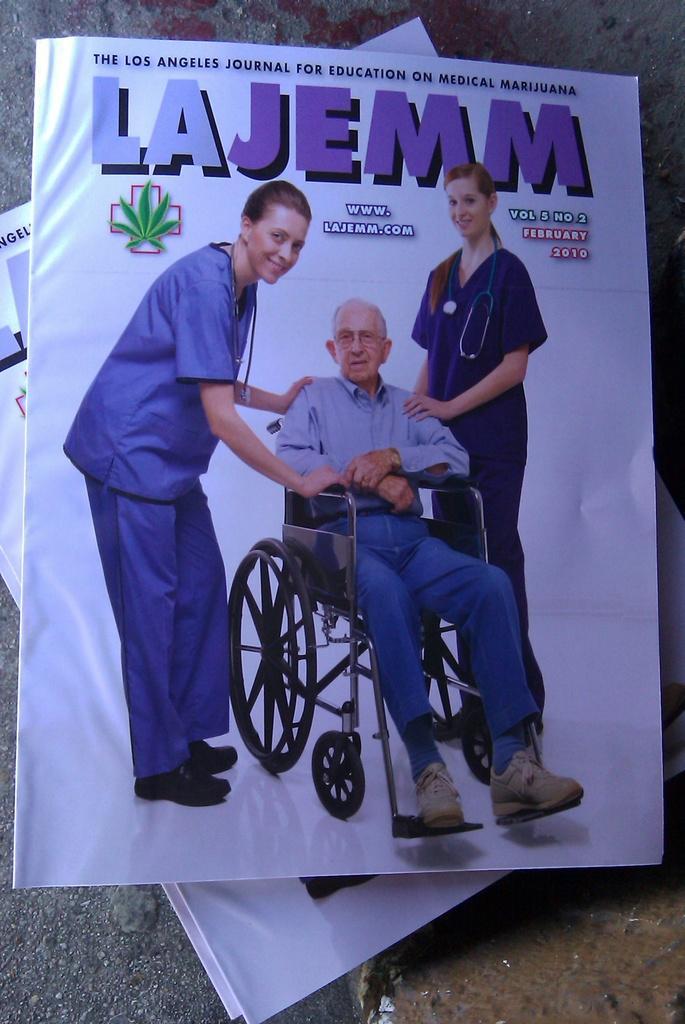How would you summarize this image in a sentence or two? In this picture we can see few books, in the book we can find two women and a man, he is seated on the wheel chair. 